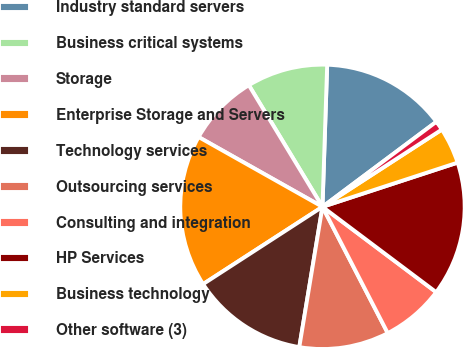Convert chart. <chart><loc_0><loc_0><loc_500><loc_500><pie_chart><fcel>Industry standard servers<fcel>Business critical systems<fcel>Storage<fcel>Enterprise Storage and Servers<fcel>Technology services<fcel>Outsourcing services<fcel>Consulting and integration<fcel>HP Services<fcel>Business technology<fcel>Other software (3)<nl><fcel>14.26%<fcel>9.19%<fcel>8.17%<fcel>17.31%<fcel>13.25%<fcel>10.2%<fcel>7.16%<fcel>15.28%<fcel>4.11%<fcel>1.07%<nl></chart> 